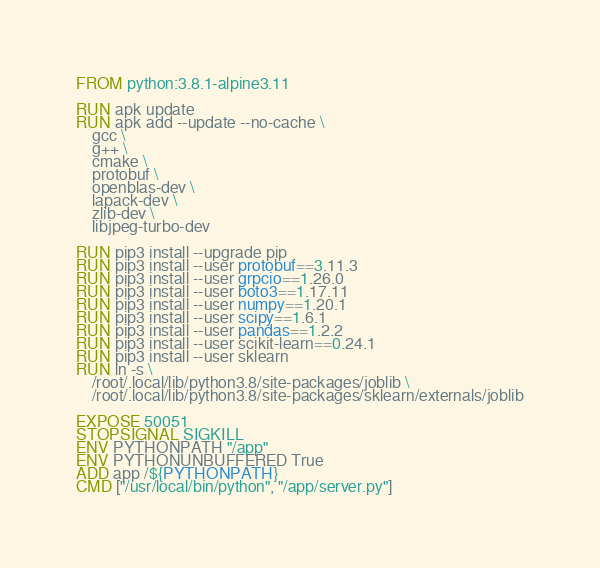<code> <loc_0><loc_0><loc_500><loc_500><_Dockerfile_>FROM python:3.8.1-alpine3.11

RUN apk update
RUN apk add --update --no-cache \
	gcc \
	g++ \
	cmake \
	protobuf \
	openblas-dev \
	lapack-dev \
	zlib-dev \
	libjpeg-turbo-dev

RUN pip3 install --upgrade pip
RUN pip3 install --user protobuf==3.11.3
RUN pip3 install --user grpcio==1.26.0
RUN pip3 install --user boto3==1.17.11
RUN pip3 install --user numpy==1.20.1
RUN pip3 install --user scipy==1.6.1
RUN pip3 install --user pandas==1.2.2
RUN pip3 install --user scikit-learn==0.24.1
RUN pip3 install --user sklearn
RUN ln -s \
	/root/.local/lib/python3.8/site-packages/joblib \
	/root/.local/lib/python3.8/site-packages/sklearn/externals/joblib

EXPOSE 50051
STOPSIGNAL SIGKILL
ENV PYTHONPATH "/app"
ENV PYTHONUNBUFFERED True
ADD app /${PYTHONPATH}
CMD ["/usr/local/bin/python", "/app/server.py"]
</code> 